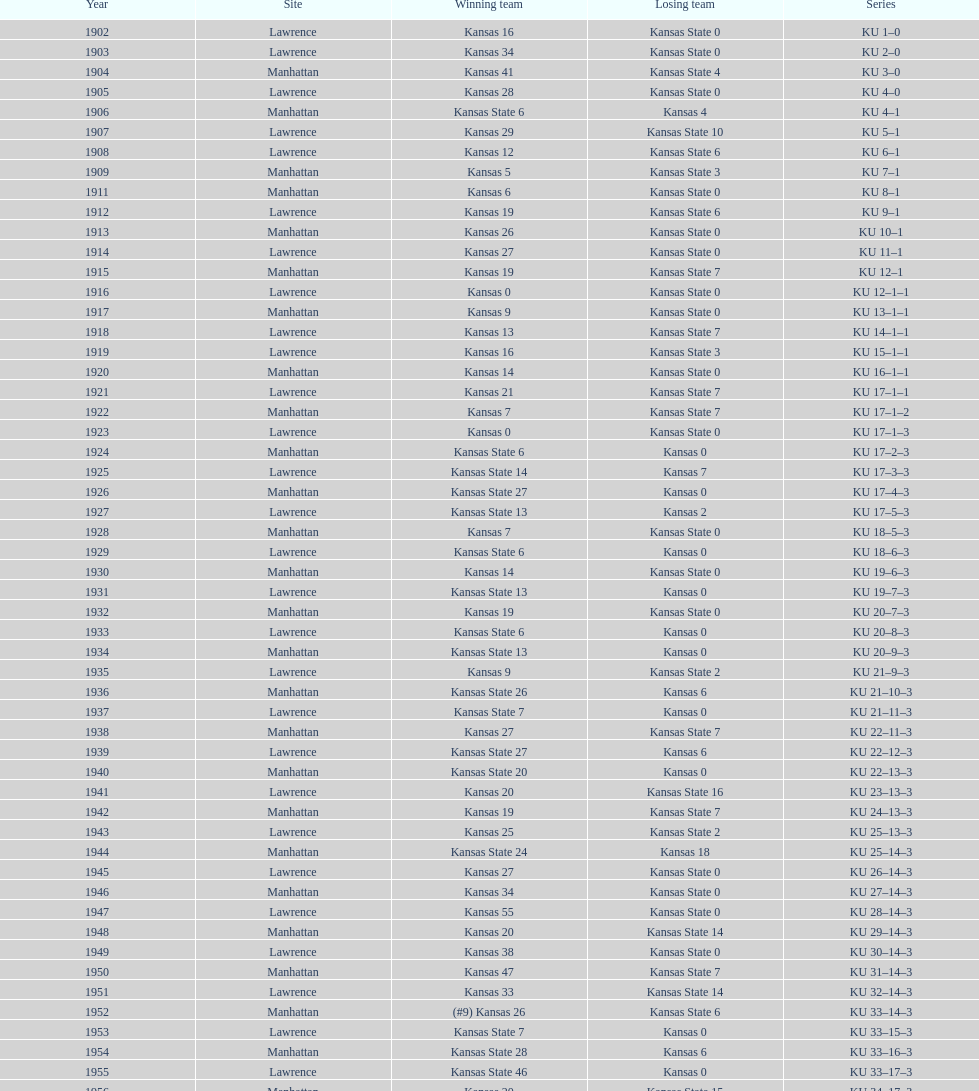Before 1950 what was the most points kansas scored? 55. 